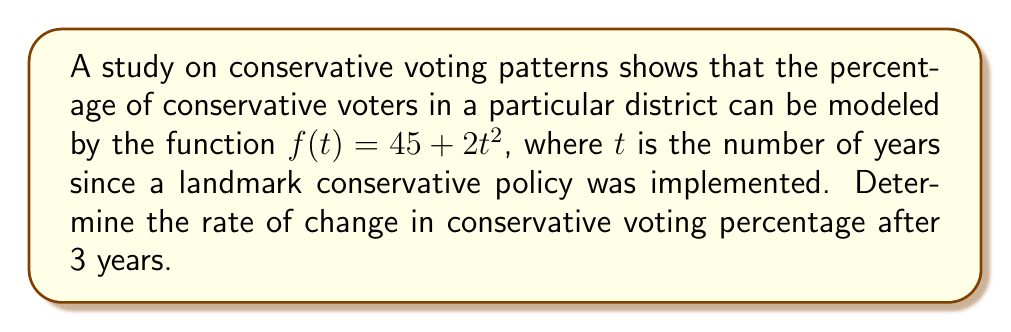Can you solve this math problem? To find the rate of change at a specific point, we need to calculate the derivative of the function and evaluate it at the given point. Let's follow these steps:

1) The given function is $f(t) = 45 + 2t^2$

2) To find the derivative, we use the power rule:
   $f'(t) = 0 + 2 \cdot 2t^1 = 4t$

3) We're asked to find the rate of change after 3 years, so we need to evaluate $f'(3)$:
   $f'(3) = 4(3) = 12$

4) Interpret the result: The rate of change after 3 years is 12 percentage points per year.

This positive slope indicates an increasing trend in conservative voting patterns, which aligns with the implementation of a landmark conservative policy.
Answer: $12$ percentage points per year 